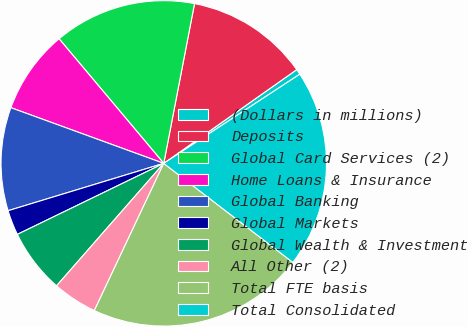Convert chart to OTSL. <chart><loc_0><loc_0><loc_500><loc_500><pie_chart><fcel>(Dollars in millions)<fcel>Deposits<fcel>Global Card Services (2)<fcel>Home Loans & Insurance<fcel>Global Banking<fcel>Global Markets<fcel>Global Wealth & Investment<fcel>All Other (2)<fcel>Total FTE basis<fcel>Total Consolidated<nl><fcel>0.54%<fcel>12.2%<fcel>14.15%<fcel>8.32%<fcel>10.26%<fcel>2.49%<fcel>6.37%<fcel>4.43%<fcel>21.6%<fcel>19.65%<nl></chart> 